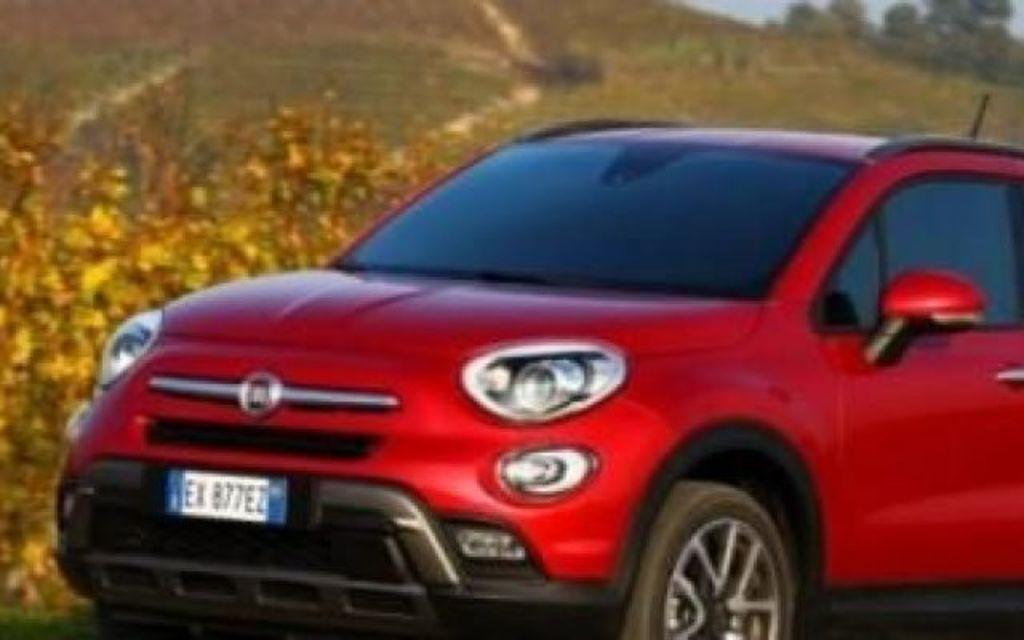What type of vehicle is in the picture? There is a red car in the picture. What else can be seen in the picture besides the car? There are plants and trees in the picture. What is the name of the person being born in the picture? There is no person being born in the picture; it features a red car, plants, and trees. 